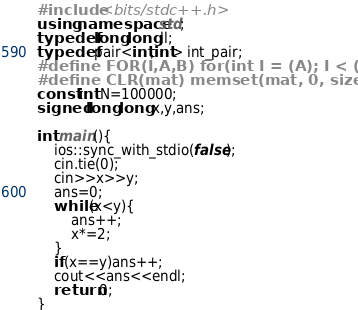<code> <loc_0><loc_0><loc_500><loc_500><_C++_>#include <bits/stdc++.h>
using namespace std;
typedef long long ll;
typedef pair<int,int> int_pair;
#define FOR(I,A,B) for(int I = (A); I < (B); ++I)
#define CLR(mat) memset(mat, 0, sizeof(mat))
const int N=100000;
signed long long x,y,ans;

int main(){
	ios::sync_with_stdio(false);
	cin.tie(0);
	cin>>x>>y;
	ans=0;
	while(x<y){
		ans++;
		x*=2;
	}
	if(x==y)ans++;
	cout<<ans<<endl;
	return 0;
}
</code> 